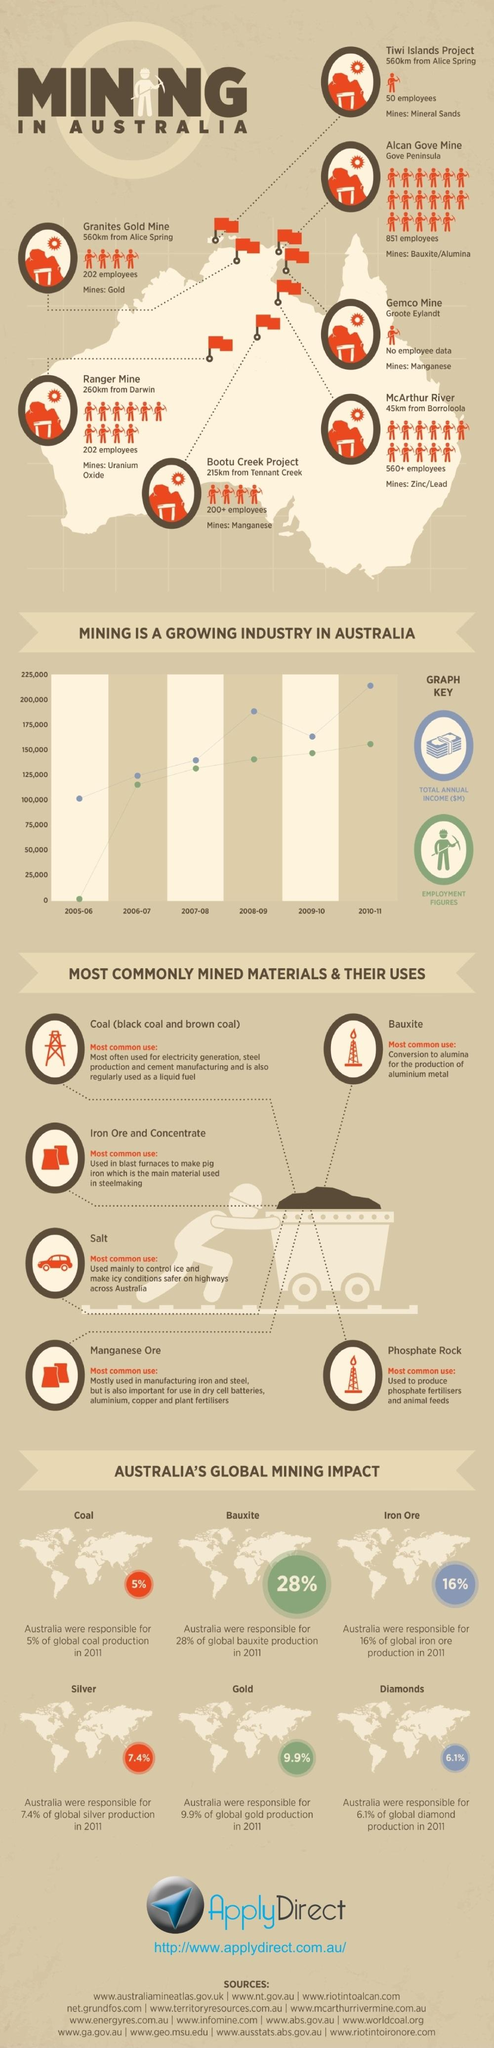Mention a couple of crucial points in this snapshot. In the year 2011, only 16% of global iron ore production came from Australia, while the remaining 84% was sourced from other countries. In 2011, only 5% of global coal production came from Australia. In the year 2011, only 9.9% of global gold production came from Australia. In the year 2011, only 6.1% of global diamond production came from Australia. In the year 2011, only 72% of the world's bauxite production originated from Australia. 